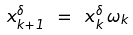Convert formula to latex. <formula><loc_0><loc_0><loc_500><loc_500>x _ { k + 1 } ^ { \delta } \ = \ x _ { k } ^ { \delta } \, \omega _ { k }</formula> 